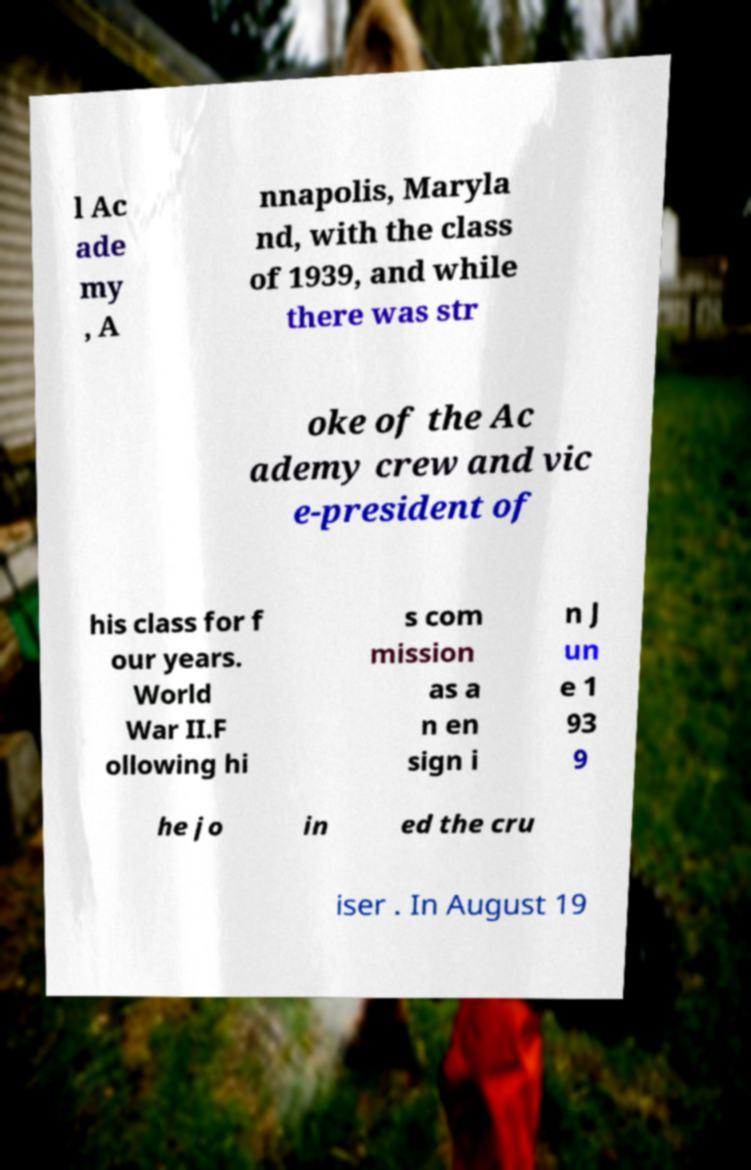Could you assist in decoding the text presented in this image and type it out clearly? l Ac ade my , A nnapolis, Maryla nd, with the class of 1939, and while there was str oke of the Ac ademy crew and vic e-president of his class for f our years. World War II.F ollowing hi s com mission as a n en sign i n J un e 1 93 9 he jo in ed the cru iser . In August 19 